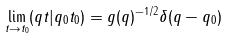<formula> <loc_0><loc_0><loc_500><loc_500>\lim _ { t \rightarrow t _ { 0 } } ( q t | q _ { 0 } t _ { 0 } ) = g ( q ) ^ { - 1 / 2 } \delta ( q - q _ { 0 } )</formula> 